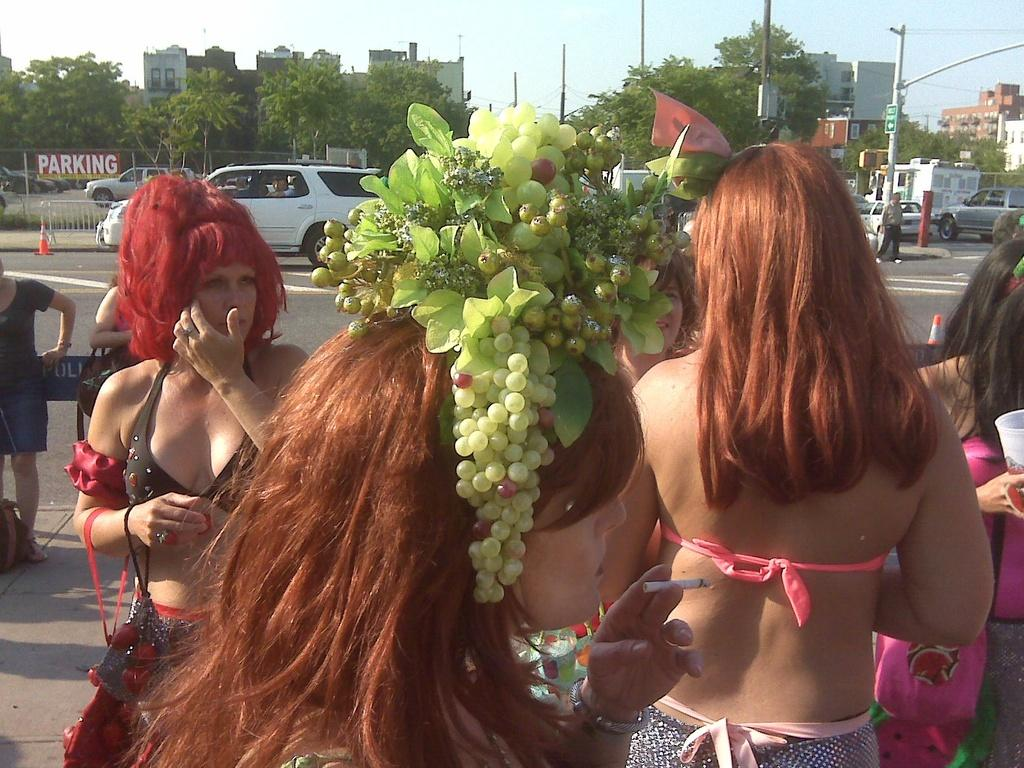What type of setting is depicted in the image? The image is an outside view. Can you describe the people in the image? There are people standing in the image, and they are wearing clothes. What other elements can be seen in the image? There are trees, buildings, and vehicles in the image. What is visible at the top of the image? The sky is visible at the top of the image. What type of mass is being held in the image? There is no indication of a mass or gathering in the image. Can you tell me how many people have died in the image? There is no indication of death or any tragic event in the image. What type of tooth is visible in the image? There is no tooth present in the image. 